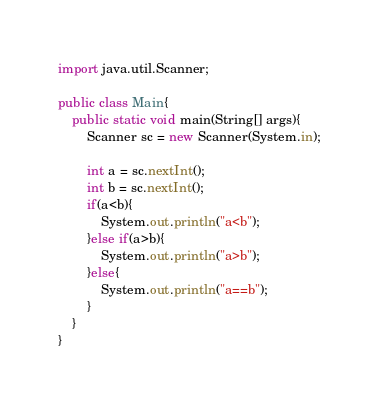<code> <loc_0><loc_0><loc_500><loc_500><_Java_>import java.util.Scanner;

public class Main{
    public static void main(String[] args){
        Scanner sc = new Scanner(System.in);

        int a = sc.nextInt();
        int b = sc.nextInt();
        if(a<b){
            System.out.println("a<b");
        }else if(a>b){
            System.out.println("a>b");
        }else{
            System.out.println("a==b");
        }
    }
}
</code> 